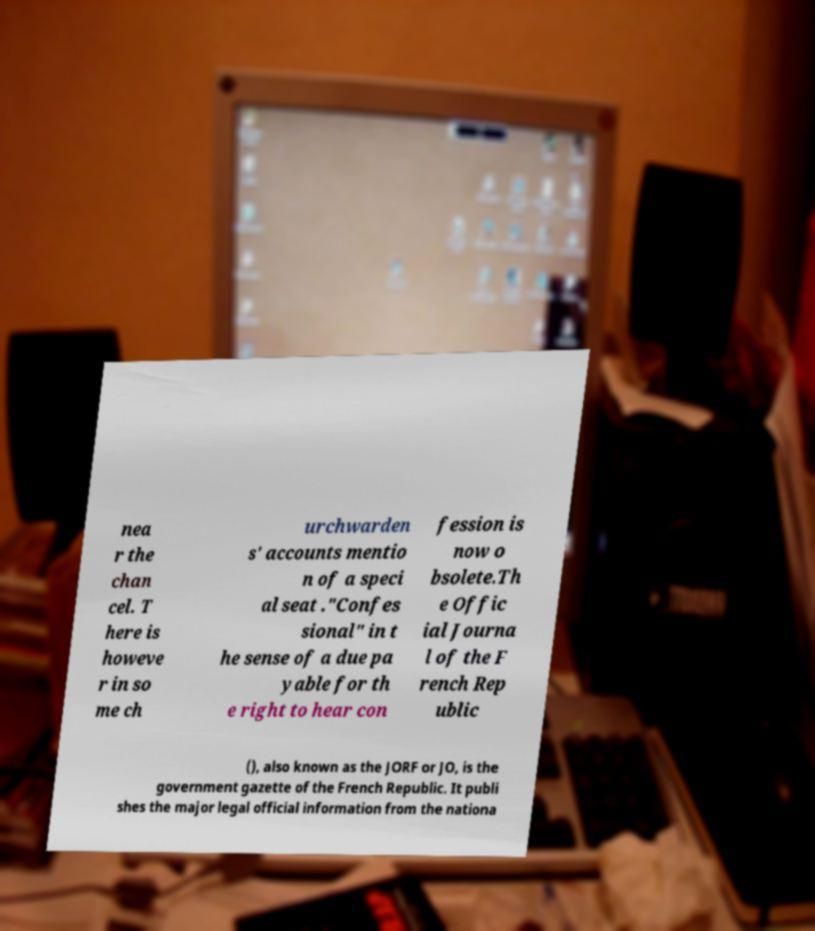Could you extract and type out the text from this image? nea r the chan cel. T here is howeve r in so me ch urchwarden s' accounts mentio n of a speci al seat ."Confes sional" in t he sense of a due pa yable for th e right to hear con fession is now o bsolete.Th e Offic ial Journa l of the F rench Rep ublic (), also known as the JORF or JO, is the government gazette of the French Republic. It publi shes the major legal official information from the nationa 